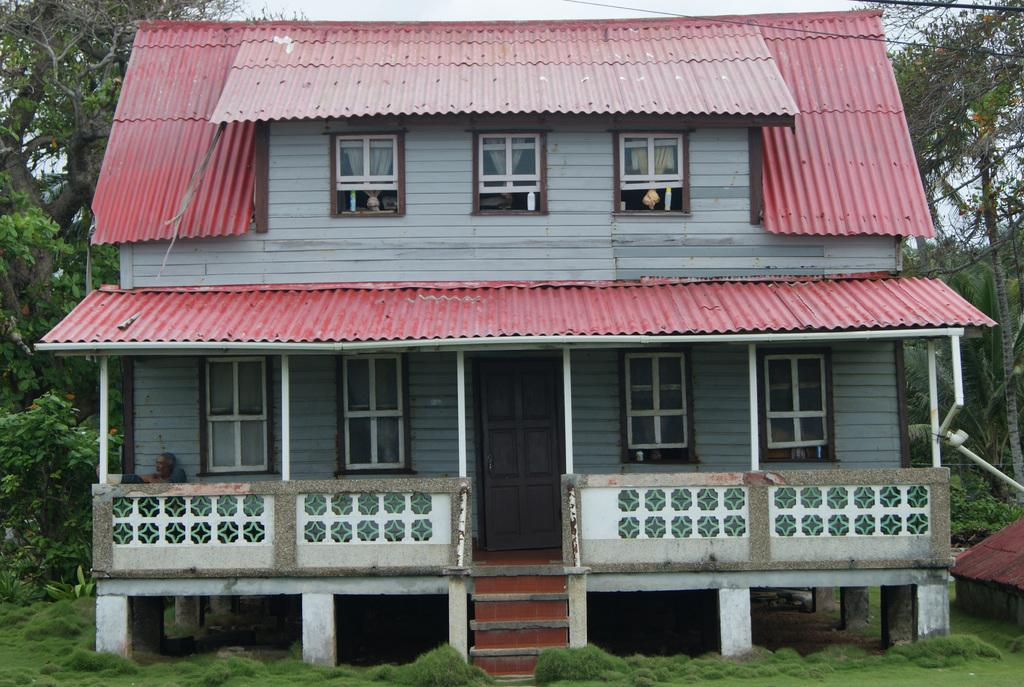What type of structure is visible in the image? There is a roof of a house in the image. What features can be seen on the house? The house has windows and a door. What architectural element is present in the image? There are stairs in the image. What type of vegetation is visible in the image? There are trees and grass in the image. What is visible in the background of the image? The sky is visible in the image. Can you describe the person in the image? There is a person on the left side of the image. Reasoning: Let's think step by step by step in order to produce the conversation. We start by identifying the main subject in the image, which is the roof of a house. Then, we expand the conversation to include other features of the house, such as windows, a door, and stairs. We also mention the presence of trees, grass, and the sky in the background. Finally, we acknowledge the presence of a person in the image. Absurd Question/Answer: What type of agreement is being discussed by the judge and doctor in the image? There is no judge or doctor present in the image, and therefore no such discussion can be observed. What type of agreement is being discussed by the judge and doctor in the image? There is no judge or doctor present in the image, and therefore no such discussion can be observed. 